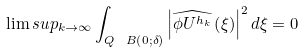Convert formula to latex. <formula><loc_0><loc_0><loc_500><loc_500>\lim s u p _ { k \rightarrow \infty } \int _ { Q \ B \left ( 0 ; \delta \right ) } \left | \widehat { \phi U ^ { h _ { k } } } \left ( \xi \right ) \right | ^ { 2 } d \xi = 0</formula> 